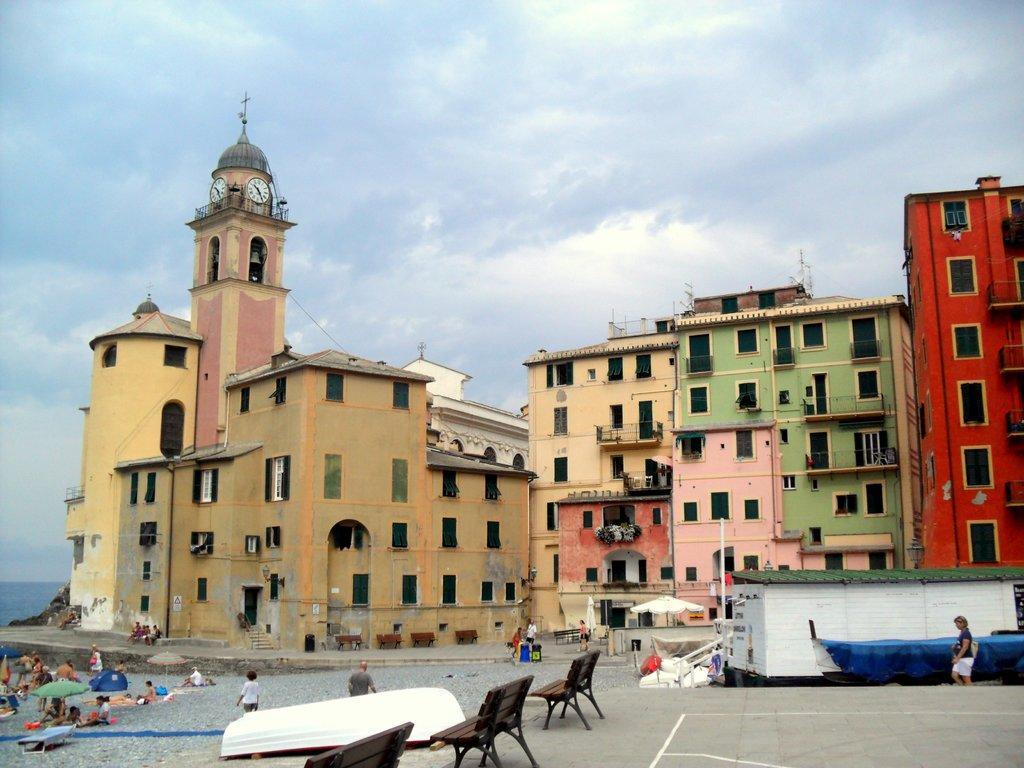Could you give a brief overview of what you see in this image? In the center of the image we can see buildings, windows, clock, poles. At the bottom of the image we can see shed, boat, some persons, benches, tents, groundwater, rocks. At the top of the image clouds are present in the sky. 